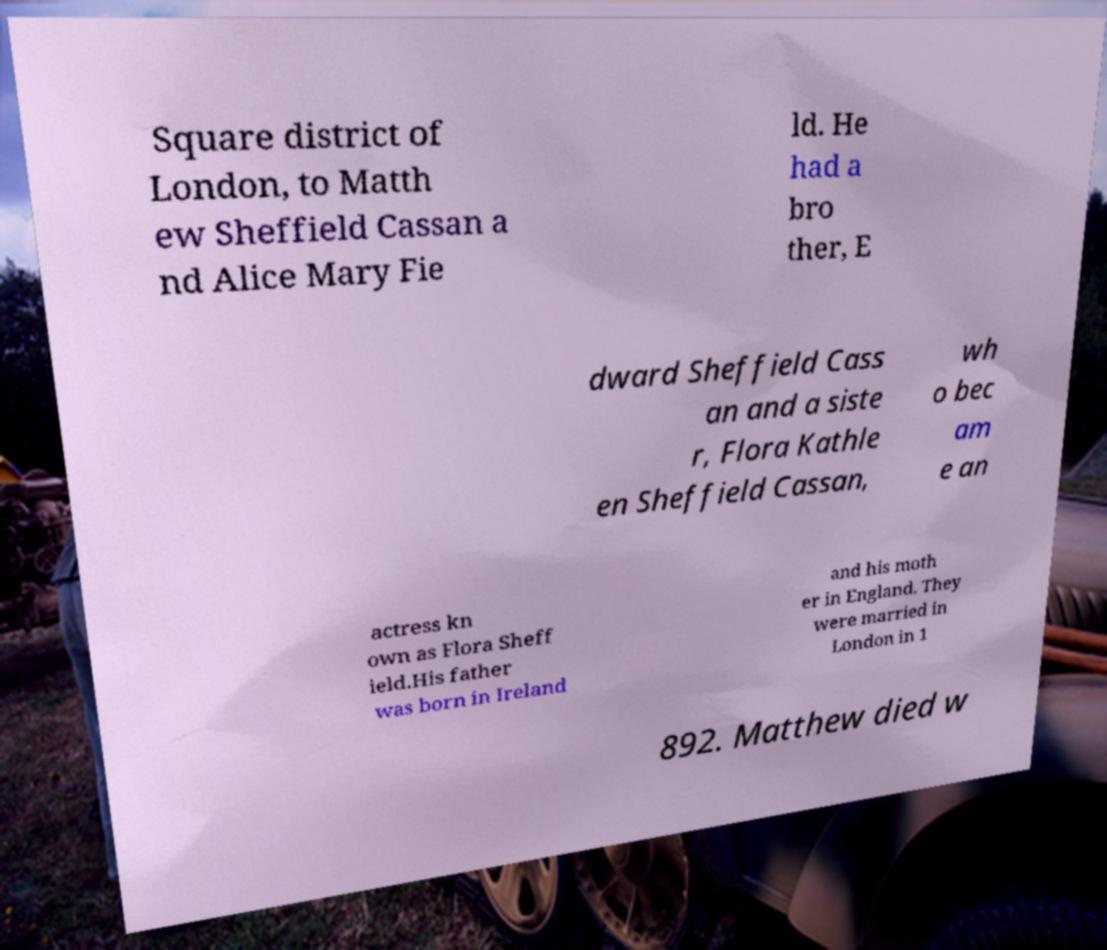Please read and relay the text visible in this image. What does it say? Square district of London, to Matth ew Sheffield Cassan a nd Alice Mary Fie ld. He had a bro ther, E dward Sheffield Cass an and a siste r, Flora Kathle en Sheffield Cassan, wh o bec am e an actress kn own as Flora Sheff ield.His father was born in Ireland and his moth er in England. They were married in London in 1 892. Matthew died w 